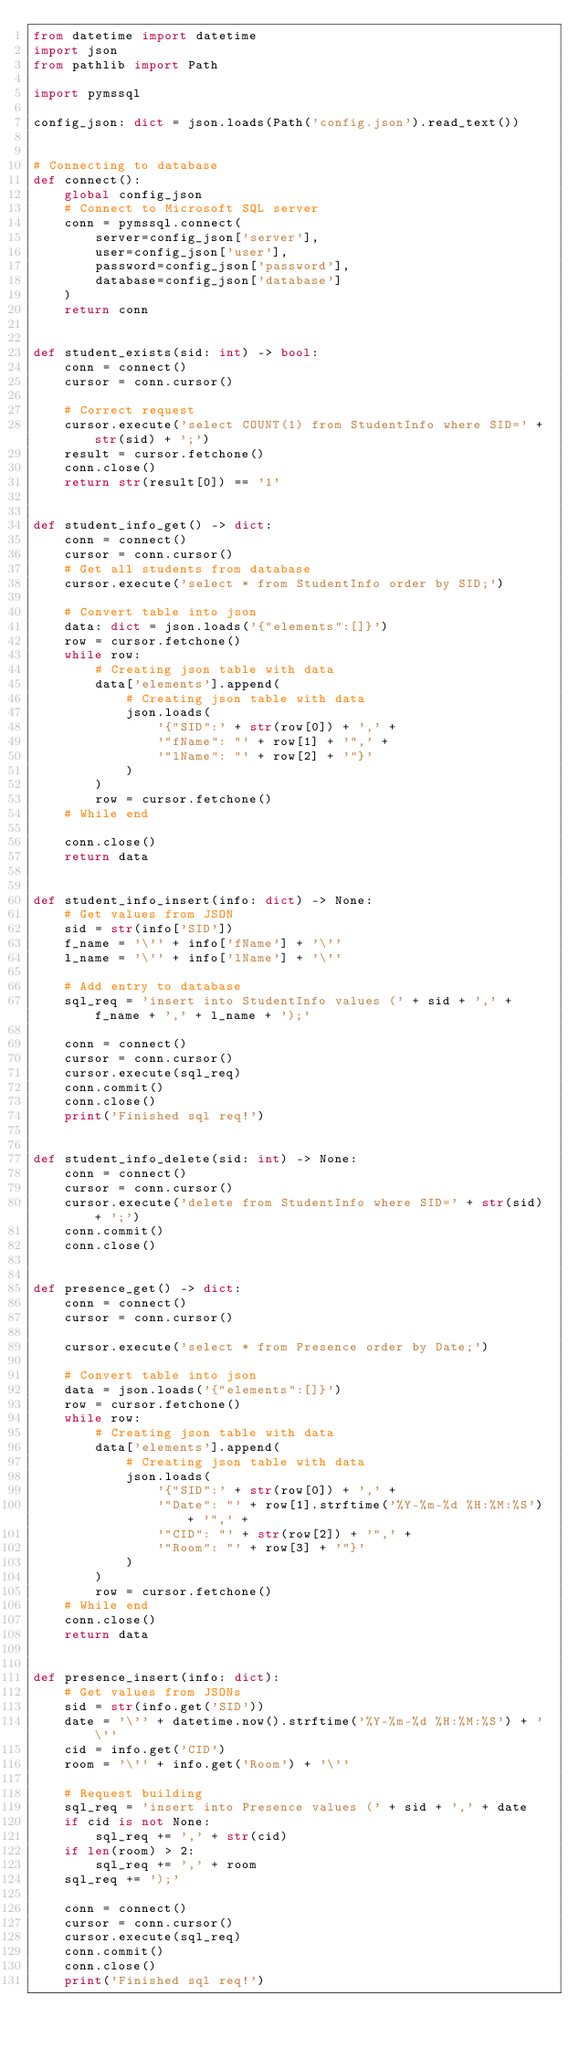Convert code to text. <code><loc_0><loc_0><loc_500><loc_500><_Python_>from datetime import datetime
import json
from pathlib import Path

import pymssql

config_json: dict = json.loads(Path('config.json').read_text())


# Connecting to database
def connect():
    global config_json
    # Connect to Microsoft SQL server
    conn = pymssql.connect(
        server=config_json['server'],
        user=config_json['user'],
        password=config_json['password'],
        database=config_json['database']
    )
    return conn


def student_exists(sid: int) -> bool:
    conn = connect()
    cursor = conn.cursor()

    # Correct request
    cursor.execute('select COUNT(1) from StudentInfo where SID=' + str(sid) + ';')
    result = cursor.fetchone()
    conn.close()
    return str(result[0]) == '1'


def student_info_get() -> dict:
    conn = connect()
    cursor = conn.cursor()
    # Get all students from database
    cursor.execute('select * from StudentInfo order by SID;')

    # Convert table into json
    data: dict = json.loads('{"elements":[]}')
    row = cursor.fetchone()
    while row:
        # Creating json table with data
        data['elements'].append(
            # Creating json table with data
            json.loads(
                '{"SID":' + str(row[0]) + ',' +
                '"fName": "' + row[1] + '",' +
                '"lName": "' + row[2] + '"}'
            )
        )
        row = cursor.fetchone()
    # While end

    conn.close()
    return data


def student_info_insert(info: dict) -> None:
    # Get values from JSON
    sid = str(info['SID'])
    f_name = '\'' + info['fName'] + '\''
    l_name = '\'' + info['lName'] + '\''

    # Add entry to database
    sql_req = 'insert into StudentInfo values (' + sid + ',' + f_name + ',' + l_name + ');'

    conn = connect()
    cursor = conn.cursor()
    cursor.execute(sql_req)
    conn.commit()
    conn.close()
    print('Finished sql req!')


def student_info_delete(sid: int) -> None:
    conn = connect()
    cursor = conn.cursor()
    cursor.execute('delete from StudentInfo where SID=' + str(sid) + ';')
    conn.commit()
    conn.close()


def presence_get() -> dict:
    conn = connect()
    cursor = conn.cursor()

    cursor.execute('select * from Presence order by Date;')

    # Convert table into json
    data = json.loads('{"elements":[]}')
    row = cursor.fetchone()
    while row:
        # Creating json table with data
        data['elements'].append(
            # Creating json table with data
            json.loads(
                '{"SID":' + str(row[0]) + ',' +
                '"Date": "' + row[1].strftime('%Y-%m-%d %H:%M:%S') + '",' +
                '"CID": "' + str(row[2]) + '",' +
                '"Room": "' + row[3] + '"}'
            )
        )
        row = cursor.fetchone()
    # While end
    conn.close()
    return data


def presence_insert(info: dict):
    # Get values from JSONs
    sid = str(info.get('SID'))
    date = '\'' + datetime.now().strftime('%Y-%m-%d %H:%M:%S') + '\''
    cid = info.get('CID')
    room = '\'' + info.get('Room') + '\''

    # Request building
    sql_req = 'insert into Presence values (' + sid + ',' + date
    if cid is not None:
        sql_req += ',' + str(cid)
    if len(room) > 2:
        sql_req += ',' + room
    sql_req += ');'

    conn = connect()
    cursor = conn.cursor()
    cursor.execute(sql_req)
    conn.commit()
    conn.close()
    print('Finished sql req!')
</code> 